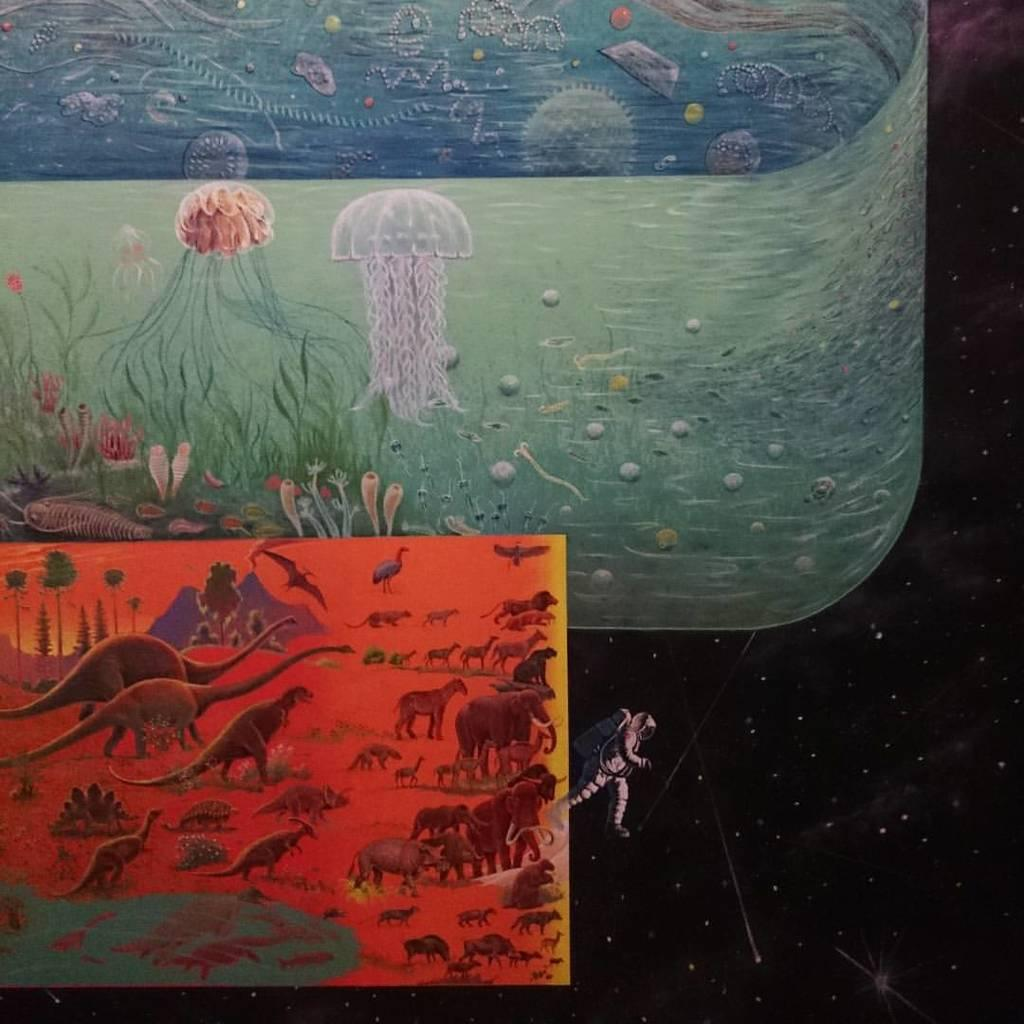What type of character is depicted in the drawings in the image? There are drawings of an astronaut in the image. What other subjects are included in the drawings? There are drawings of animals, trees, hills, and jellyfish in the image. Can you describe the setting or environment depicted in the drawings? The drawings depict a landscape that includes trees, hills, and possibly other objects. How does the image show an increase in the number of eggnog cups? The image does not show any eggnog cups, nor does it depict an increase in their number. 